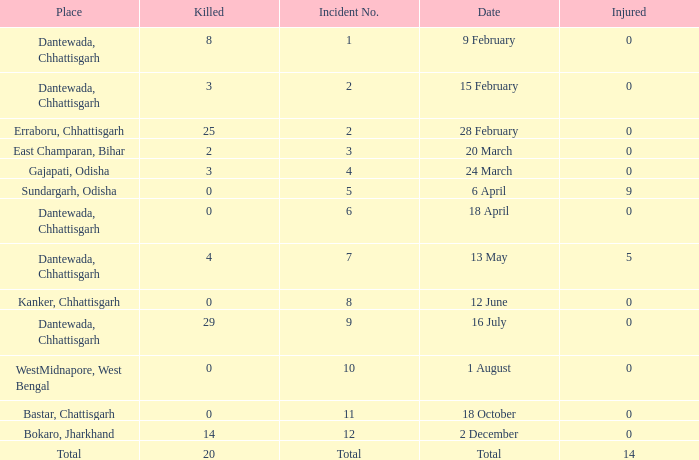Can you give me this table as a dict? {'header': ['Place', 'Killed', 'Incident No.', 'Date', 'Injured'], 'rows': [['Dantewada, Chhattisgarh', '8', '1', '9 February', '0'], ['Dantewada, Chhattisgarh', '3', '2', '15 February', '0'], ['Erraboru, Chhattisgarh', '25', '2', '28 February', '0'], ['East Champaran, Bihar', '2', '3', '20 March', '0'], ['Gajapati, Odisha', '3', '4', '24 March', '0'], ['Sundargarh, Odisha', '0', '5', '6 April', '9'], ['Dantewada, Chhattisgarh', '0', '6', '18 April', '0'], ['Dantewada, Chhattisgarh', '4', '7', '13 May', '5'], ['Kanker, Chhattisgarh', '0', '8', '12 June', '0'], ['Dantewada, Chhattisgarh', '29', '9', '16 July', '0'], ['WestMidnapore, West Bengal', '0', '10', '1 August', '0'], ['Bastar, Chattisgarh', '0', '11', '18 October', '0'], ['Bokaro, Jharkhand', '14', '12', '2 December', '0'], ['Total', '20', 'Total', 'Total', '14']]} What is the least amount of injuries in Dantewada, Chhattisgarh when 8 people were killed? 0.0. 